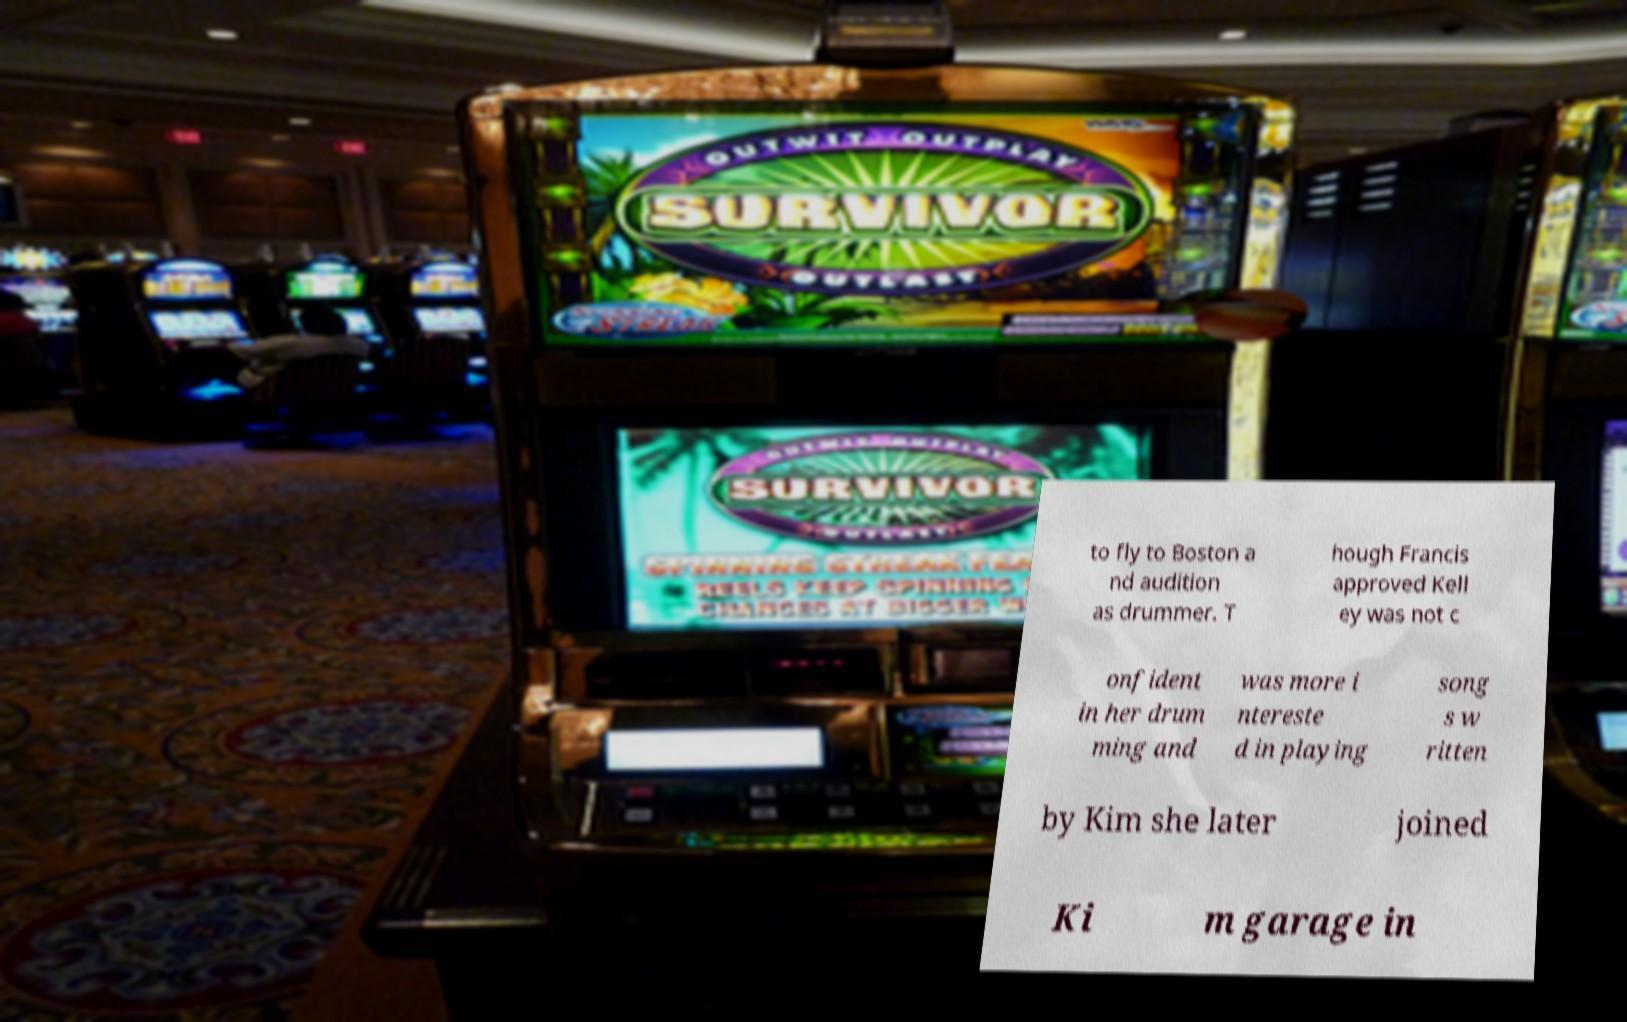For documentation purposes, I need the text within this image transcribed. Could you provide that? to fly to Boston a nd audition as drummer. T hough Francis approved Kell ey was not c onfident in her drum ming and was more i ntereste d in playing song s w ritten by Kim she later joined Ki m garage in 